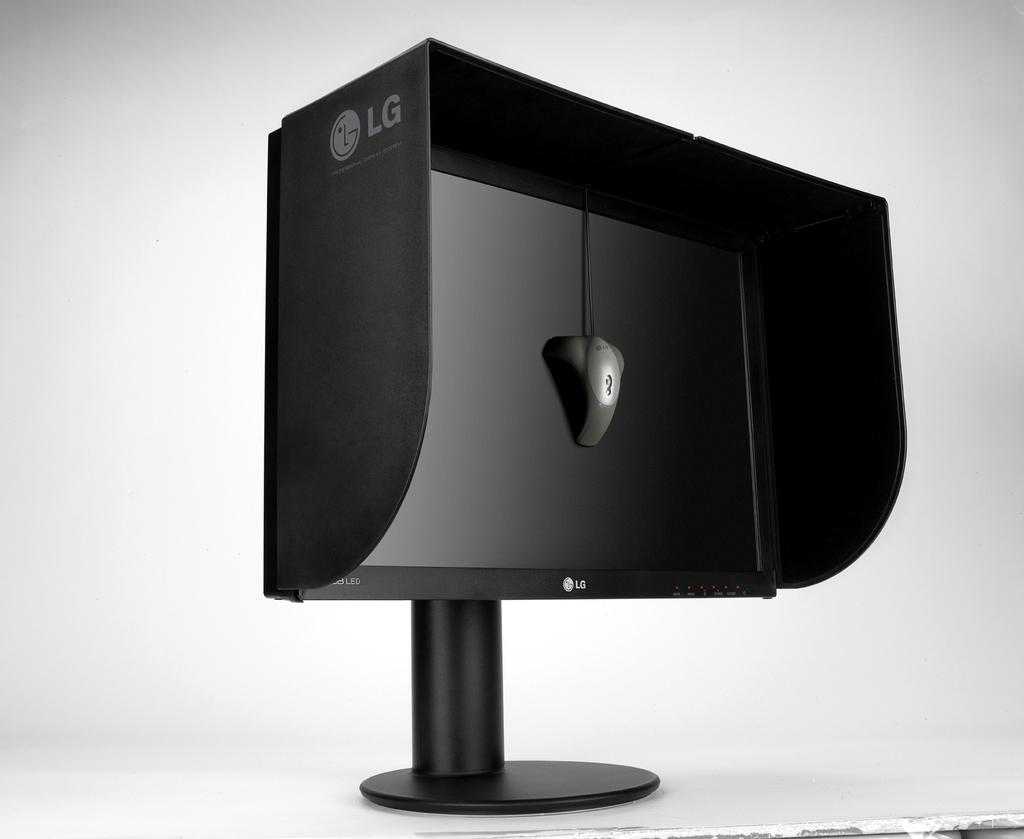<image>
Offer a succinct explanation of the picture presented. An LG branded black monitor with the side covers included on it. 